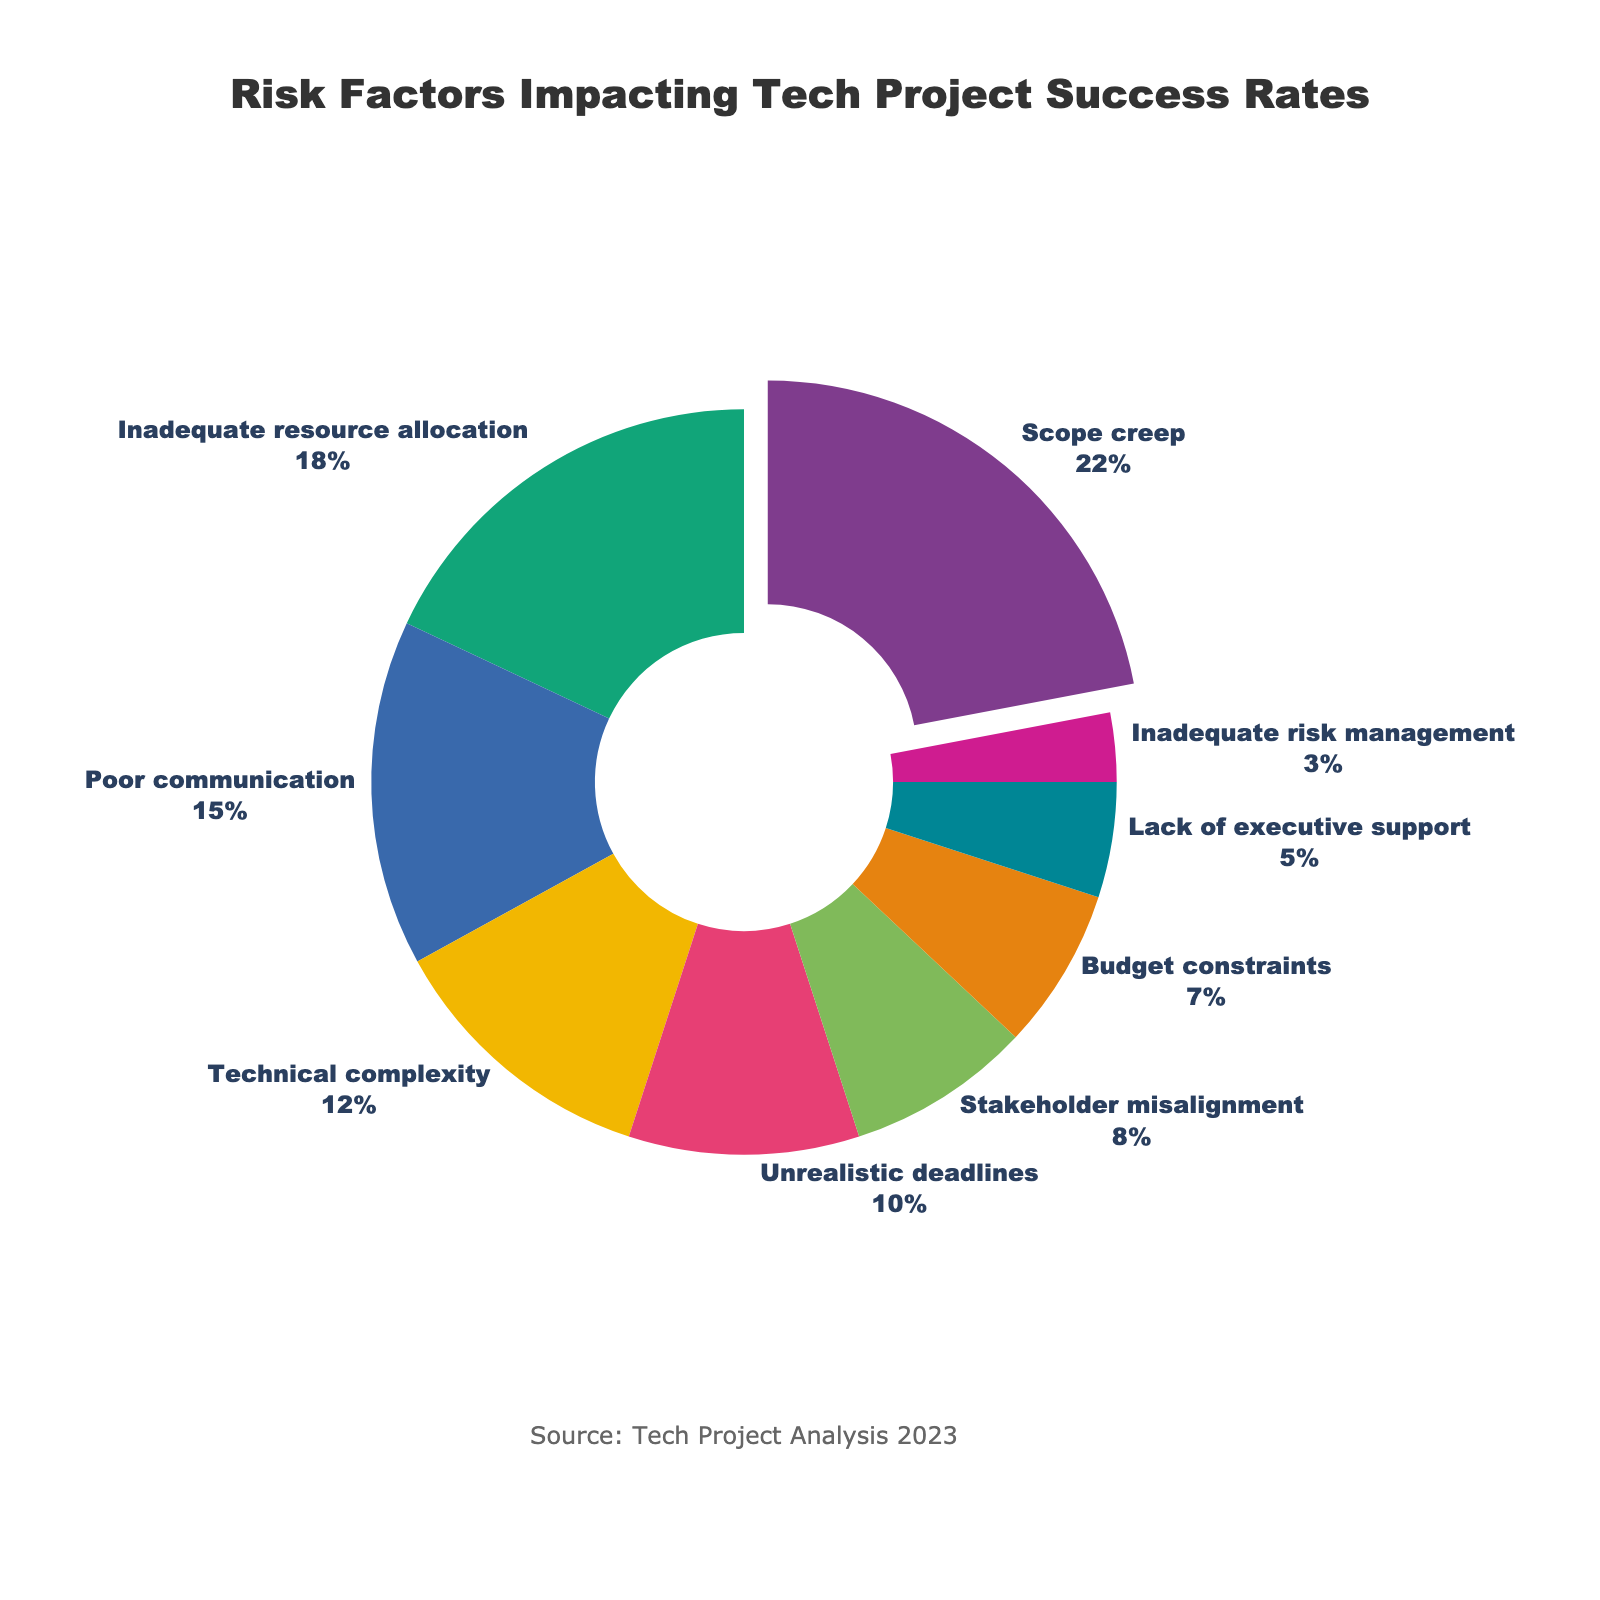What is the largest risk factor impacting tech project success rates? The pie chart sorts the indices from highest to lowest. The largest segment is the one pulled out slightly, representing "Scope creep" with 22%.
Answer: Scope creep How much more significant is Scope creep compared to Inadequate resource allocation? The percentage for "Scope creep" is 22% and for "Inadequate resource allocation" is 18%. Calculate the difference: 22% - 18% = 4%.
Answer: 4% Which three risk factors combined form almost half of the total risk? The top three risk factors are "Scope creep" (22%), "Inadequate resource allocation" (18%), and "Poor communication" (15%). Summing them up: 22% + 18% + 15% = 55%.
Answer: Scope creep, Inadequate resource allocation, Poor communication What percentage of the risk factors are related to management and planning issues? Identifying the relevant factors: Scope creep (22%), Inadequate resource allocation (18%), Poor communication (15%), Unrealistic deadlines (10%), Stakeholder misalignment (8%), Budget constraints (7%), Lack of executive support (5%), Inadequate risk management (3%). Summing them up: 22% + 18% + 15% + 10% + 8% + 7% + 5% + 3% = 88%.
Answer: 88% Which risk factors constitute less than 10% each? Identifying factors below 10%: Stakeholder misalignment (8%), Budget constraints (7%), Lack of executive support (5%), Inadequate risk management (3%).
Answer: Stakeholder misalignment, Budget constraints, Lack of executive support, Inadequate risk management By how much does Poor communication surpass Technical complexity in terms of percentage? The pie chart shows 15% for "Poor communication" and 12% for "Technical complexity". The difference is: 15% - 12% = 3%.
Answer: 3% What is the median value of the risk factors? Sorting the percentages: 3%, 5%, 7%, 8%, 10%, 12%, 15%, 18%, 22%. The median is the middle value in the sorted list, which is 10%.
Answer: 10% Which is the least significant risk factor? The smallest segment in the pie chart, representing "Inadequate risk management," has a percentage of 3%.
Answer: Inadequate risk management What is the combined percentage of Technical complexity and Unrealistic deadlines? The pie chart shows 12% for "Technical complexity" and 10% for "Unrealistic deadlines". Summing them up: 12% + 10% = 22%.
Answer: 22% What visual attribute indicates the most significant risk factor on the pie chart? The pie chart segment for the most significant factor, Scope creep, is slightly pulled out from the rest of the chart, highlighting its importance.
Answer: Pulled-out segment 